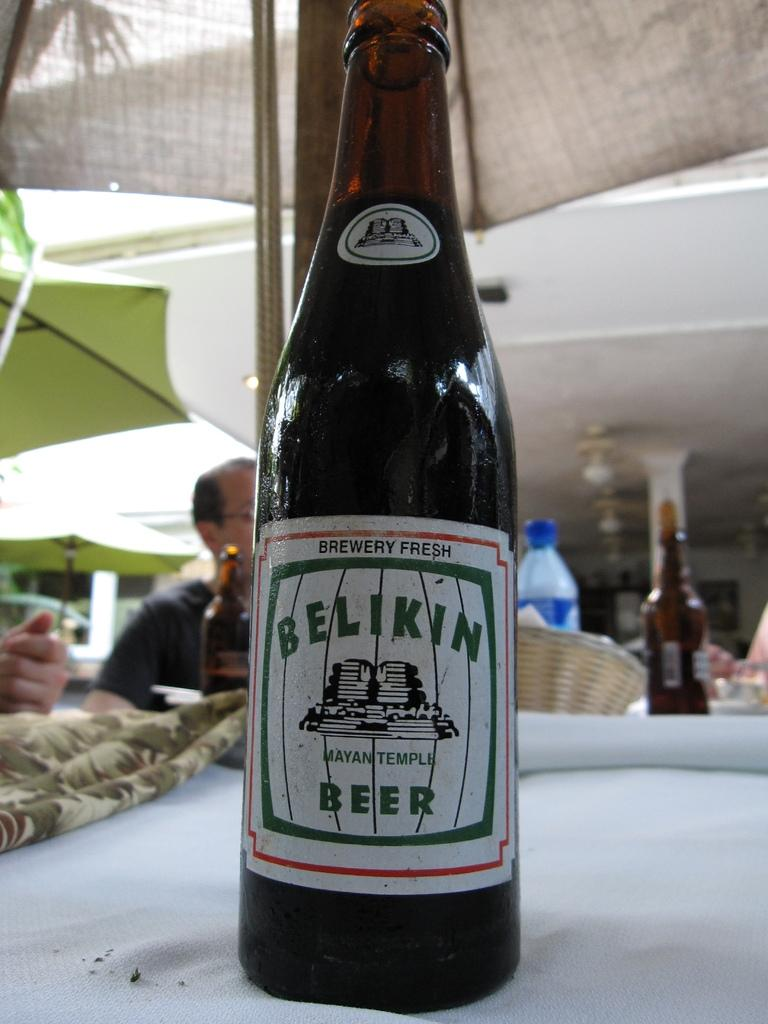<image>
Offer a succinct explanation of the picture presented. A bottle has the brand name Belikin on it. 